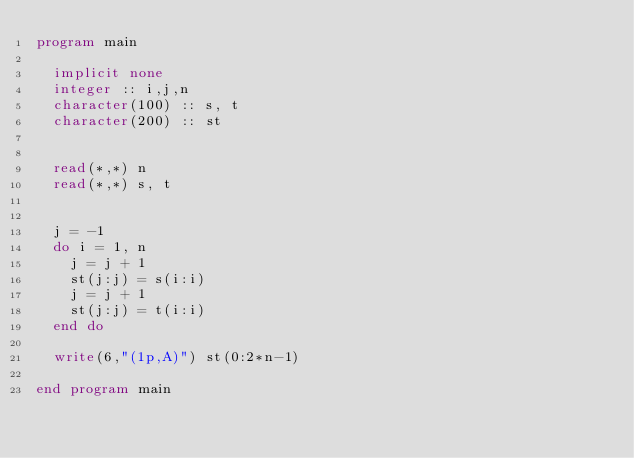Convert code to text. <code><loc_0><loc_0><loc_500><loc_500><_FORTRAN_>program main

  implicit none
  integer :: i,j,n
  character(100) :: s, t
  character(200) :: st


  read(*,*) n
  read(*,*) s, t


  j = -1
  do i = 1, n
    j = j + 1
    st(j:j) = s(i:i)
    j = j + 1
    st(j:j) = t(i:i)
  end do

  write(6,"(1p,A)") st(0:2*n-1)

end program main</code> 